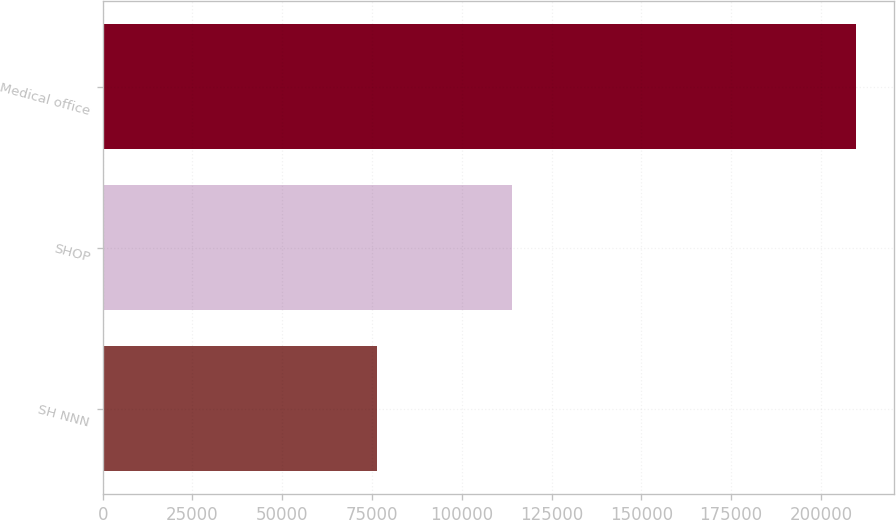Convert chart to OTSL. <chart><loc_0><loc_0><loc_500><loc_500><bar_chart><fcel>SH NNN<fcel>SHOP<fcel>Medical office<nl><fcel>76362<fcel>113971<fcel>209920<nl></chart> 